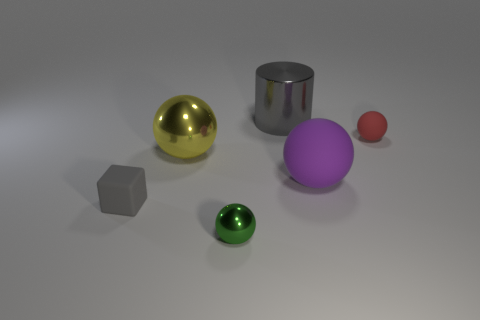Subtract all blue balls. Subtract all blue cylinders. How many balls are left? 4 Add 2 big blocks. How many objects exist? 8 Subtract all balls. How many objects are left? 2 Add 4 small rubber blocks. How many small rubber blocks are left? 5 Add 5 spheres. How many spheres exist? 9 Subtract 1 red spheres. How many objects are left? 5 Subtract all tiny gray rubber objects. Subtract all large objects. How many objects are left? 2 